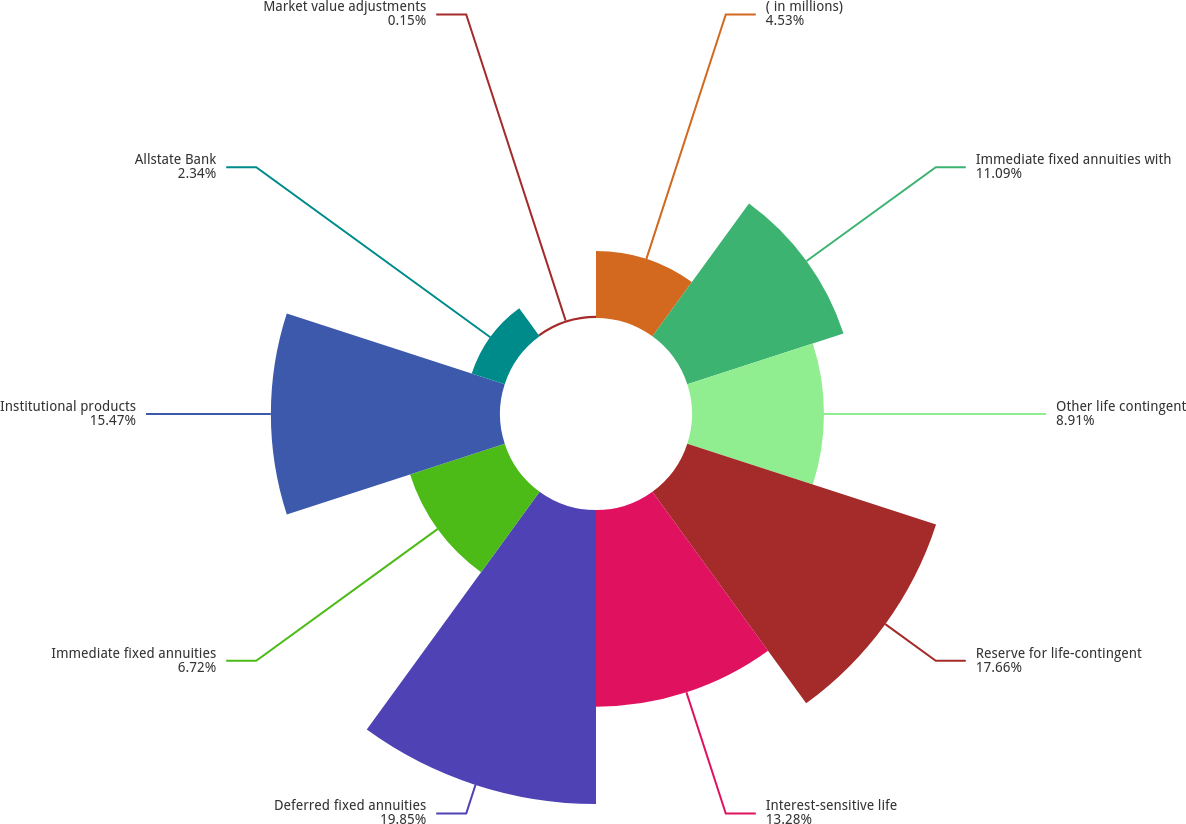Convert chart to OTSL. <chart><loc_0><loc_0><loc_500><loc_500><pie_chart><fcel>( in millions)<fcel>Immediate fixed annuities with<fcel>Other life contingent<fcel>Reserve for life-contingent<fcel>Interest-sensitive life<fcel>Deferred fixed annuities<fcel>Immediate fixed annuities<fcel>Institutional products<fcel>Allstate Bank<fcel>Market value adjustments<nl><fcel>4.53%<fcel>11.09%<fcel>8.91%<fcel>17.66%<fcel>13.28%<fcel>19.85%<fcel>6.72%<fcel>15.47%<fcel>2.34%<fcel>0.15%<nl></chart> 